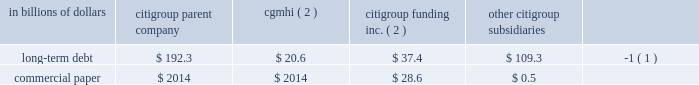Sources of liquidity primary sources of liquidity for citigroup and its principal subsidiaries include : 2022 deposits ; 2022 collateralized financing transactions ; 2022 senior and subordinated debt ; 2022 commercial paper ; 2022 trust preferred and preferred securities ; and 2022 purchased/wholesale funds .
Citigroup 2019s funding sources are diversified across funding types and geography , a benefit of its global franchise .
Funding for citigroup and its major operating subsidiaries includes a geographically diverse retail and corporate deposit base of $ 774.2 billion .
These deposits are diversified across products and regions , with approximately two-thirds of them outside of the u.s .
This diversification provides the company with an important , stable and low-cost source of funding .
A significant portion of these deposits has been , and is expected to be , long-term and stable , and are considered to be core .
There are qualitative as well as quantitative assessments that determine the company 2019s calculation of core deposits .
The first step in this process is a qualitative assessment of the deposits .
For example , as a result of the company 2019s qualitative analysis certain deposits with wholesale funding characteristics are excluded from consideration as core .
Deposits that qualify under the company 2019s qualitative assessments are then subjected to quantitative analysis .
Excluding the impact of changes in foreign exchange rates and the sale of our retail banking operations in germany during the year ending december 31 , 2008 , the company 2019s deposit base remained stable .
On a volume basis , deposit increases were noted in transaction services , u.s .
Retail banking and smith barney .
This was partially offset by the company 2019s decision to reduce deposits considered wholesale funding , consistent with the company 2019s de-leveraging efforts , and declines in international consumer banking and the private bank .
Citigroup and its subsidiaries have historically had a significant presence in the global capital markets .
The company 2019s capital markets funding activities have been primarily undertaken by two legal entities : ( i ) citigroup inc. , which issues long-term debt , medium-term notes , trust preferred securities , and preferred and common stock ; and ( ii ) citigroup funding inc .
( cfi ) , a first-tier subsidiary of citigroup , which issues commercial paper , medium-term notes and structured equity-linked and credit-linked notes , all of which are guaranteed by citigroup .
Other significant elements of long- term debt on the consolidated balance sheet include collateralized advances from the federal home loan bank system , long-term debt related to the consolidation of icg 2019s structured investment vehicles , asset-backed outstandings , and certain borrowings of foreign subsidiaries .
Each of citigroup 2019s major operating subsidiaries finances its operations on a basis consistent with its capitalization , regulatory structure and the environment in which it operates .
Particular attention is paid to those businesses that for tax , sovereign risk , or regulatory reasons cannot be freely and readily funded in the international markets .
Citigroup 2019s borrowings have historically been diversified by geography , investor , instrument and currency .
Decisions regarding the ultimate currency and interest rate profile of liquidity generated through these borrowings can be separated from the actual issuance through the use of derivative instruments .
Citigroup is a provider of liquidity facilities to the commercial paper programs of the two primary credit card securitization trusts with which it transacts .
Citigroup may also provide other types of support to the trusts .
As a result of the recent economic downturn , its impact on the cashflows of the trusts , and in response to credit rating agency reviews of the trusts , the company increased the credit enhancement in the omni trust , and plans to provide additional enhancement to the master trust ( see note 23 to consolidated financial statements on page 175 for a further discussion ) .
This support preserves investor sponsorship of our card securitization franchise , an important source of liquidity .
Banking subsidiaries there are various legal limitations on the ability of citigroup 2019s subsidiary depository institutions to extend credit , pay dividends or otherwise supply funds to citigroup and its non-bank subsidiaries .
The approval of the office of the comptroller of the currency , in the case of national banks , or the office of thrift supervision , in the case of federal savings banks , is required if total dividends declared in any calendar year exceed amounts specified by the applicable agency 2019s regulations .
State-chartered depository institutions are subject to dividend limitations imposed by applicable state law .
In determining the declaration of dividends , each depository institution must also consider its effect on applicable risk-based capital and leverage ratio requirements , as well as policy statements of the federal regulatory agencies that indicate that banking organizations should generally pay dividends out of current operating earnings .
Non-banking subsidiaries citigroup also receives dividends from its non-bank subsidiaries .
These non-bank subsidiaries are generally not subject to regulatory restrictions on dividends .
However , as discussed in 201ccapital resources and liquidity 201d on page 94 , the ability of cgmhi to declare dividends can be restricted by capital considerations of its broker-dealer subsidiaries .
Cgmhi 2019s consolidated balance sheet is liquid , with the vast majority of its assets consisting of marketable securities and collateralized short-term financing agreements arising from securities transactions .
Cgmhi monitors and evaluates the adequacy of its capital and borrowing base on a daily basis to maintain liquidity and to ensure that its capital base supports the regulatory capital requirements of its subsidiaries .
Some of citigroup 2019s non-bank subsidiaries , including cgmhi , have credit facilities with citigroup 2019s subsidiary depository institutions , including citibank , n.a .
Borrowings under these facilities must be secured in accordance with section 23a of the federal reserve act .
There are various legal restrictions on the extent to which a bank holding company and certain of its non-bank subsidiaries can borrow or obtain credit from citigroup 2019s subsidiary depository institutions or engage in certain other transactions with them .
In general , these restrictions require that transactions be on arm 2019s length terms and be secured by designated amounts of specified collateral .
See note 20 to the consolidated financial statements on page 169 .
At december 31 , 2008 , long-term debt and commercial paper outstanding for citigroup , cgmhi , cfi and citigroup 2019s subsidiaries were as follows : in billions of dollars citigroup parent company cgmhi ( 2 ) citigroup funding inc .
( 2 ) citigroup subsidiaries long-term debt $ 192.3 $ 20.6 $ 37.4 $ 109.3 ( 1 ) .
( 1 ) at december 31 , 2008 , approximately $ 67.4 billion relates to collateralized advances from the federal home loan bank .
( 2 ) citigroup inc .
Guarantees all of cfi 2019s debt and cgmhi 2019s publicly issued securities. .
In 2008 what was the ratio of the citigroup parent company to the other citigroup subsidiaries long-term debt? 
Computations: (192.3 / 109.3)
Answer: 1.75938. 